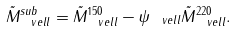<formula> <loc_0><loc_0><loc_500><loc_500>\tilde { M } ^ { s u b } _ { \ v e l l } = \tilde { M } ^ { 1 5 0 } _ { \ v e l l } - \psi _ { \ v e l l } \tilde { M } ^ { 2 2 0 } _ { \ v e l l } .</formula> 